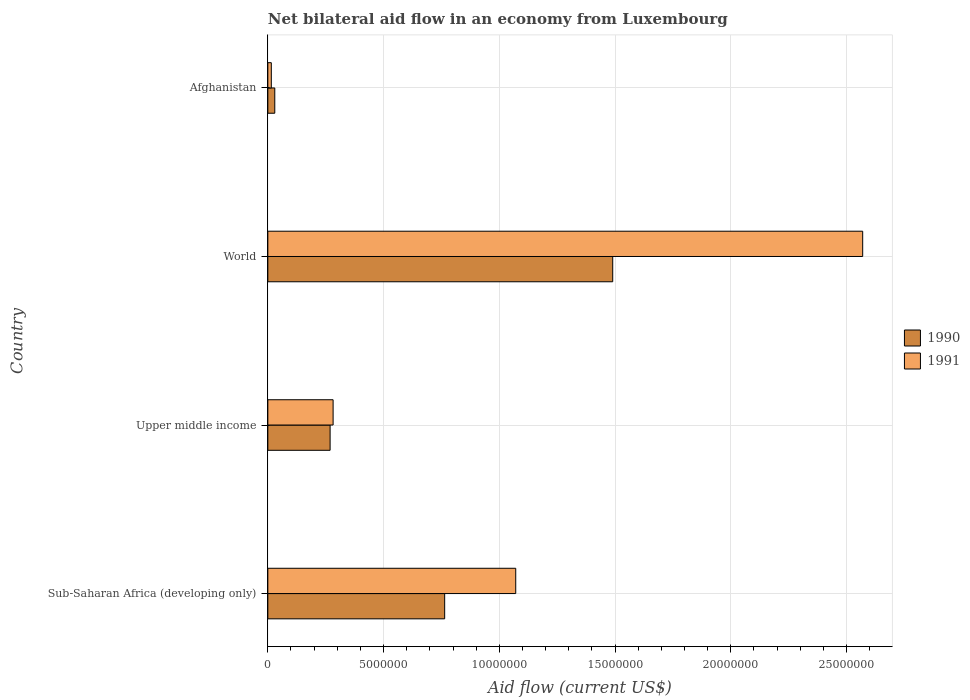How many different coloured bars are there?
Your answer should be very brief. 2. How many groups of bars are there?
Offer a terse response. 4. Are the number of bars per tick equal to the number of legend labels?
Provide a short and direct response. Yes. Are the number of bars on each tick of the Y-axis equal?
Make the answer very short. Yes. How many bars are there on the 3rd tick from the top?
Your answer should be very brief. 2. What is the label of the 4th group of bars from the top?
Give a very brief answer. Sub-Saharan Africa (developing only). What is the net bilateral aid flow in 1991 in Sub-Saharan Africa (developing only)?
Provide a short and direct response. 1.07e+07. Across all countries, what is the maximum net bilateral aid flow in 1990?
Give a very brief answer. 1.49e+07. In which country was the net bilateral aid flow in 1991 minimum?
Offer a terse response. Afghanistan. What is the total net bilateral aid flow in 1991 in the graph?
Offer a very short reply. 3.94e+07. What is the difference between the net bilateral aid flow in 1991 in Afghanistan and that in World?
Keep it short and to the point. -2.56e+07. What is the difference between the net bilateral aid flow in 1991 in Upper middle income and the net bilateral aid flow in 1990 in Sub-Saharan Africa (developing only)?
Your response must be concise. -4.82e+06. What is the average net bilateral aid flow in 1990 per country?
Keep it short and to the point. 6.38e+06. What is the difference between the net bilateral aid flow in 1991 and net bilateral aid flow in 1990 in World?
Your answer should be compact. 1.08e+07. What is the ratio of the net bilateral aid flow in 1990 in Afghanistan to that in Upper middle income?
Offer a very short reply. 0.11. Is the net bilateral aid flow in 1990 in Upper middle income less than that in World?
Your answer should be very brief. Yes. Is the difference between the net bilateral aid flow in 1991 in Sub-Saharan Africa (developing only) and Upper middle income greater than the difference between the net bilateral aid flow in 1990 in Sub-Saharan Africa (developing only) and Upper middle income?
Your answer should be very brief. Yes. What is the difference between the highest and the second highest net bilateral aid flow in 1991?
Keep it short and to the point. 1.50e+07. What is the difference between the highest and the lowest net bilateral aid flow in 1990?
Your answer should be very brief. 1.46e+07. Is the sum of the net bilateral aid flow in 1990 in Afghanistan and Sub-Saharan Africa (developing only) greater than the maximum net bilateral aid flow in 1991 across all countries?
Ensure brevity in your answer.  No. What does the 2nd bar from the bottom in Upper middle income represents?
Ensure brevity in your answer.  1991. Are all the bars in the graph horizontal?
Your answer should be compact. Yes. How many countries are there in the graph?
Make the answer very short. 4. What is the difference between two consecutive major ticks on the X-axis?
Your response must be concise. 5.00e+06. Are the values on the major ticks of X-axis written in scientific E-notation?
Provide a succinct answer. No. Does the graph contain grids?
Keep it short and to the point. Yes. Where does the legend appear in the graph?
Your answer should be very brief. Center right. How many legend labels are there?
Make the answer very short. 2. How are the legend labels stacked?
Make the answer very short. Vertical. What is the title of the graph?
Offer a terse response. Net bilateral aid flow in an economy from Luxembourg. Does "1989" appear as one of the legend labels in the graph?
Offer a terse response. No. What is the label or title of the X-axis?
Keep it short and to the point. Aid flow (current US$). What is the Aid flow (current US$) of 1990 in Sub-Saharan Africa (developing only)?
Your response must be concise. 7.64e+06. What is the Aid flow (current US$) in 1991 in Sub-Saharan Africa (developing only)?
Provide a succinct answer. 1.07e+07. What is the Aid flow (current US$) of 1990 in Upper middle income?
Make the answer very short. 2.69e+06. What is the Aid flow (current US$) in 1991 in Upper middle income?
Your answer should be very brief. 2.82e+06. What is the Aid flow (current US$) of 1990 in World?
Give a very brief answer. 1.49e+07. What is the Aid flow (current US$) of 1991 in World?
Ensure brevity in your answer.  2.57e+07. Across all countries, what is the maximum Aid flow (current US$) of 1990?
Ensure brevity in your answer.  1.49e+07. Across all countries, what is the maximum Aid flow (current US$) in 1991?
Offer a very short reply. 2.57e+07. What is the total Aid flow (current US$) in 1990 in the graph?
Your response must be concise. 2.55e+07. What is the total Aid flow (current US$) in 1991 in the graph?
Your answer should be compact. 3.94e+07. What is the difference between the Aid flow (current US$) of 1990 in Sub-Saharan Africa (developing only) and that in Upper middle income?
Give a very brief answer. 4.95e+06. What is the difference between the Aid flow (current US$) of 1991 in Sub-Saharan Africa (developing only) and that in Upper middle income?
Provide a short and direct response. 7.89e+06. What is the difference between the Aid flow (current US$) of 1990 in Sub-Saharan Africa (developing only) and that in World?
Your response must be concise. -7.26e+06. What is the difference between the Aid flow (current US$) in 1991 in Sub-Saharan Africa (developing only) and that in World?
Ensure brevity in your answer.  -1.50e+07. What is the difference between the Aid flow (current US$) in 1990 in Sub-Saharan Africa (developing only) and that in Afghanistan?
Keep it short and to the point. 7.34e+06. What is the difference between the Aid flow (current US$) in 1991 in Sub-Saharan Africa (developing only) and that in Afghanistan?
Provide a succinct answer. 1.06e+07. What is the difference between the Aid flow (current US$) in 1990 in Upper middle income and that in World?
Your answer should be compact. -1.22e+07. What is the difference between the Aid flow (current US$) in 1991 in Upper middle income and that in World?
Offer a terse response. -2.29e+07. What is the difference between the Aid flow (current US$) of 1990 in Upper middle income and that in Afghanistan?
Keep it short and to the point. 2.39e+06. What is the difference between the Aid flow (current US$) in 1991 in Upper middle income and that in Afghanistan?
Make the answer very short. 2.67e+06. What is the difference between the Aid flow (current US$) in 1990 in World and that in Afghanistan?
Give a very brief answer. 1.46e+07. What is the difference between the Aid flow (current US$) in 1991 in World and that in Afghanistan?
Give a very brief answer. 2.56e+07. What is the difference between the Aid flow (current US$) of 1990 in Sub-Saharan Africa (developing only) and the Aid flow (current US$) of 1991 in Upper middle income?
Provide a succinct answer. 4.82e+06. What is the difference between the Aid flow (current US$) in 1990 in Sub-Saharan Africa (developing only) and the Aid flow (current US$) in 1991 in World?
Ensure brevity in your answer.  -1.81e+07. What is the difference between the Aid flow (current US$) of 1990 in Sub-Saharan Africa (developing only) and the Aid flow (current US$) of 1991 in Afghanistan?
Provide a succinct answer. 7.49e+06. What is the difference between the Aid flow (current US$) of 1990 in Upper middle income and the Aid flow (current US$) of 1991 in World?
Provide a short and direct response. -2.30e+07. What is the difference between the Aid flow (current US$) of 1990 in Upper middle income and the Aid flow (current US$) of 1991 in Afghanistan?
Offer a terse response. 2.54e+06. What is the difference between the Aid flow (current US$) in 1990 in World and the Aid flow (current US$) in 1991 in Afghanistan?
Give a very brief answer. 1.48e+07. What is the average Aid flow (current US$) in 1990 per country?
Keep it short and to the point. 6.38e+06. What is the average Aid flow (current US$) of 1991 per country?
Provide a short and direct response. 9.84e+06. What is the difference between the Aid flow (current US$) of 1990 and Aid flow (current US$) of 1991 in Sub-Saharan Africa (developing only)?
Your answer should be very brief. -3.07e+06. What is the difference between the Aid flow (current US$) of 1990 and Aid flow (current US$) of 1991 in Upper middle income?
Provide a short and direct response. -1.30e+05. What is the difference between the Aid flow (current US$) in 1990 and Aid flow (current US$) in 1991 in World?
Keep it short and to the point. -1.08e+07. What is the ratio of the Aid flow (current US$) in 1990 in Sub-Saharan Africa (developing only) to that in Upper middle income?
Make the answer very short. 2.84. What is the ratio of the Aid flow (current US$) of 1991 in Sub-Saharan Africa (developing only) to that in Upper middle income?
Offer a very short reply. 3.8. What is the ratio of the Aid flow (current US$) of 1990 in Sub-Saharan Africa (developing only) to that in World?
Provide a short and direct response. 0.51. What is the ratio of the Aid flow (current US$) of 1991 in Sub-Saharan Africa (developing only) to that in World?
Make the answer very short. 0.42. What is the ratio of the Aid flow (current US$) in 1990 in Sub-Saharan Africa (developing only) to that in Afghanistan?
Make the answer very short. 25.47. What is the ratio of the Aid flow (current US$) in 1991 in Sub-Saharan Africa (developing only) to that in Afghanistan?
Your answer should be very brief. 71.4. What is the ratio of the Aid flow (current US$) of 1990 in Upper middle income to that in World?
Give a very brief answer. 0.18. What is the ratio of the Aid flow (current US$) in 1991 in Upper middle income to that in World?
Keep it short and to the point. 0.11. What is the ratio of the Aid flow (current US$) of 1990 in Upper middle income to that in Afghanistan?
Ensure brevity in your answer.  8.97. What is the ratio of the Aid flow (current US$) of 1991 in Upper middle income to that in Afghanistan?
Provide a short and direct response. 18.8. What is the ratio of the Aid flow (current US$) in 1990 in World to that in Afghanistan?
Your answer should be compact. 49.67. What is the ratio of the Aid flow (current US$) in 1991 in World to that in Afghanistan?
Your response must be concise. 171.33. What is the difference between the highest and the second highest Aid flow (current US$) in 1990?
Keep it short and to the point. 7.26e+06. What is the difference between the highest and the second highest Aid flow (current US$) in 1991?
Your answer should be compact. 1.50e+07. What is the difference between the highest and the lowest Aid flow (current US$) in 1990?
Give a very brief answer. 1.46e+07. What is the difference between the highest and the lowest Aid flow (current US$) in 1991?
Keep it short and to the point. 2.56e+07. 